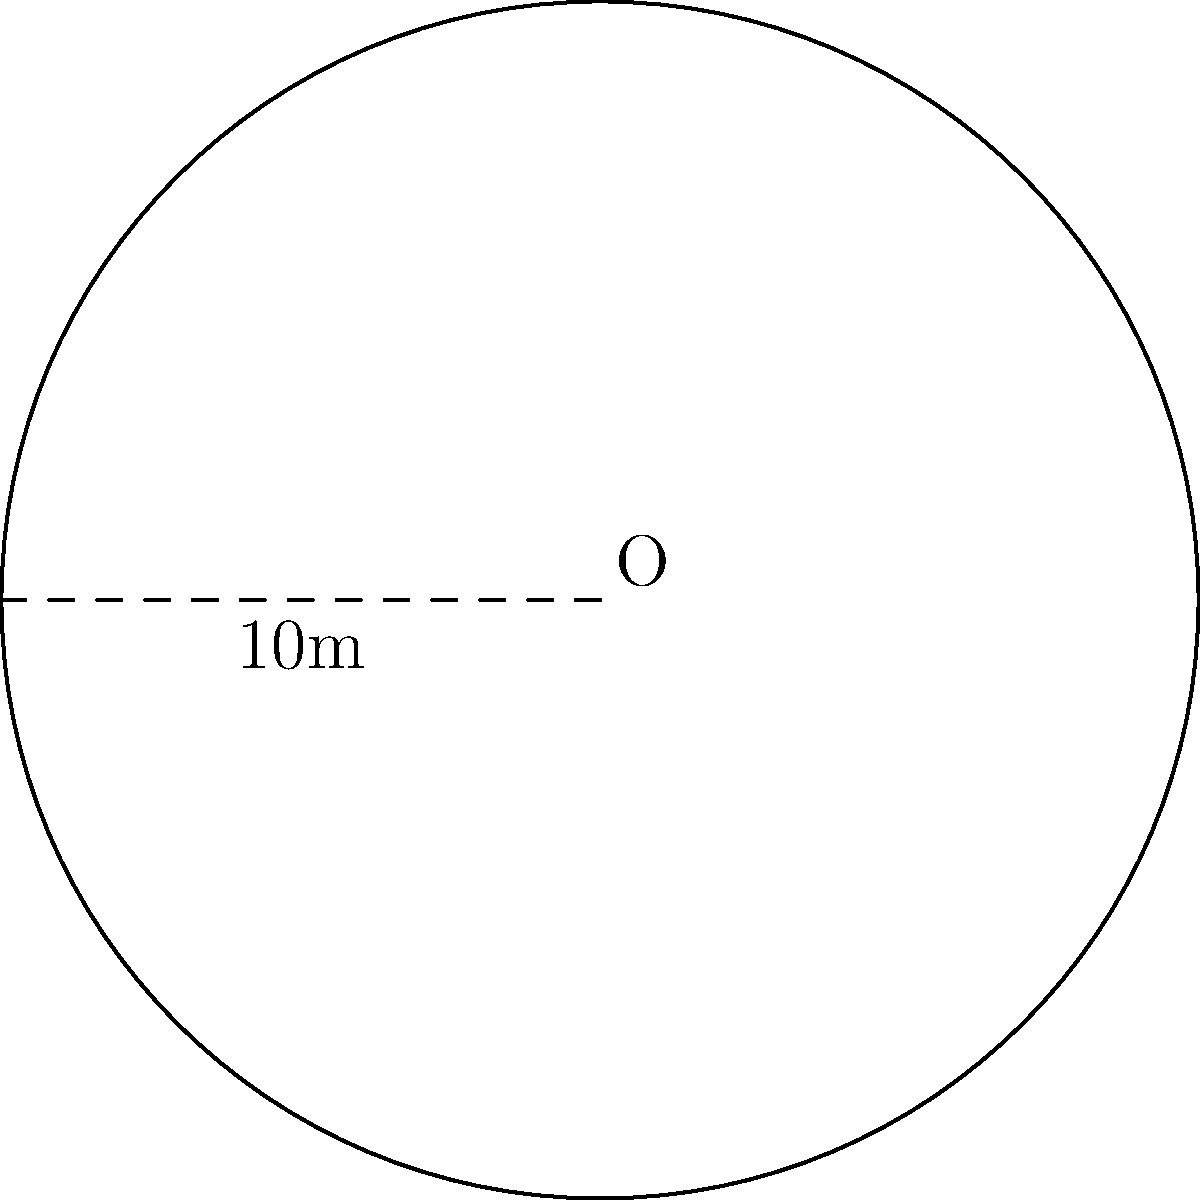A circular garden in Townsville is being dedicated to James Cook, the famous explorer who named the town. The garden's diameter is 10 meters. What is the area of this commemorative garden? To find the area of the circular garden, we need to follow these steps:

1) The formula for the area of a circle is $A = \pi r^2$, where $r$ is the radius.

2) We are given the diameter, which is 10 meters. The radius is half of the diameter.
   $r = \frac{10}{2} = 5$ meters

3) Now we can substitute this into our formula:
   $A = \pi (5)^2$

4) Simplify:
   $A = 25\pi$ square meters

5) If we need a numerical answer, we can use $\pi \approx 3.14159$:
   $A \approx 25 * 3.14159 = 78.53975$ square meters

Therefore, the area of the garden is $25\pi$ or approximately 78.54 square meters.
Answer: $25\pi$ m² (or approximately 78.54 m²) 